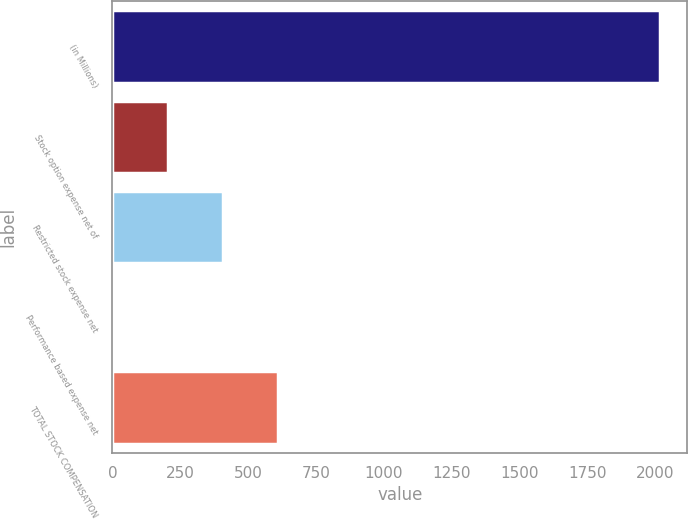<chart> <loc_0><loc_0><loc_500><loc_500><bar_chart><fcel>(in Millions)<fcel>Stock option expense net of<fcel>Restricted stock expense net<fcel>Performance based expense net<fcel>TOTAL STOCK COMPENSATION<nl><fcel>2018<fcel>205.76<fcel>407.12<fcel>4.4<fcel>608.48<nl></chart> 